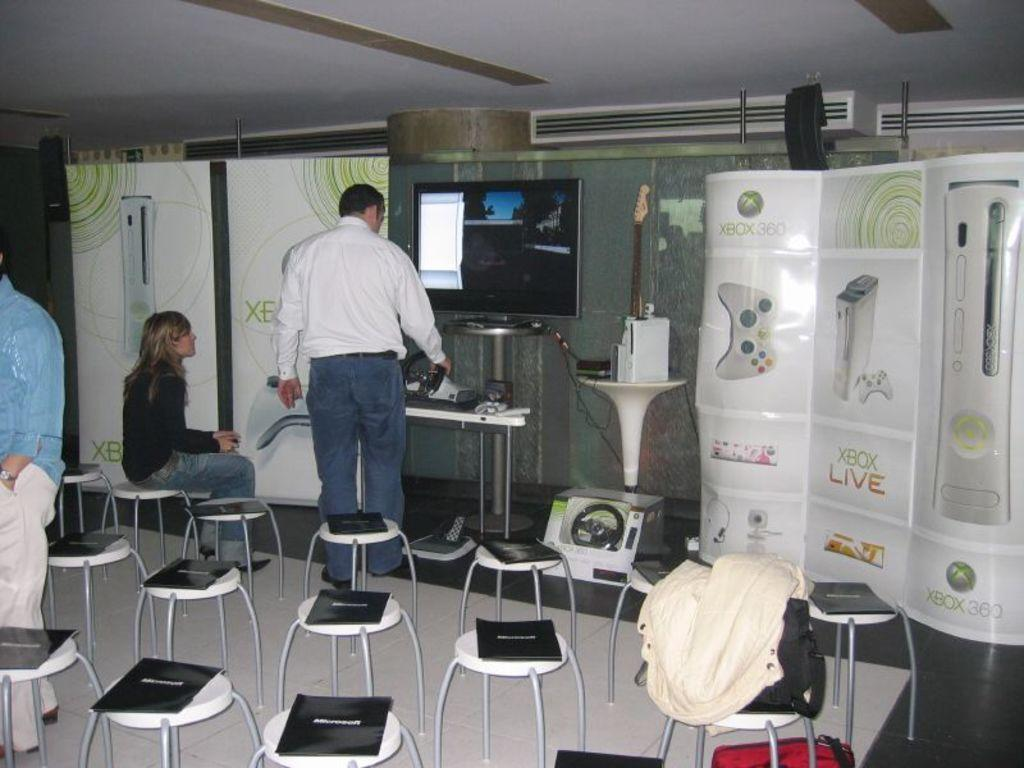<image>
Present a compact description of the photo's key features. A seminar or gamer test for Xbox Live 